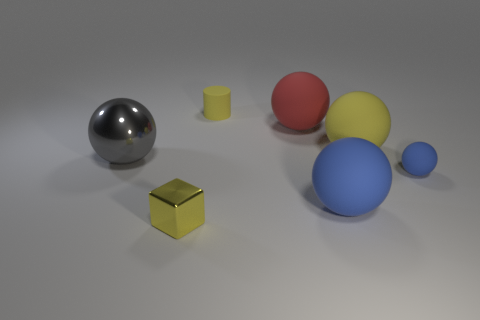Subtract all yellow balls. How many balls are left? 4 Subtract 1 balls. How many balls are left? 4 Add 2 cylinders. How many objects exist? 9 Subtract all cylinders. How many objects are left? 6 Add 7 large matte objects. How many large matte objects are left? 10 Add 3 tiny blue matte things. How many tiny blue matte things exist? 4 Subtract 0 gray cylinders. How many objects are left? 7 Subtract all tiny yellow objects. Subtract all blue matte objects. How many objects are left? 3 